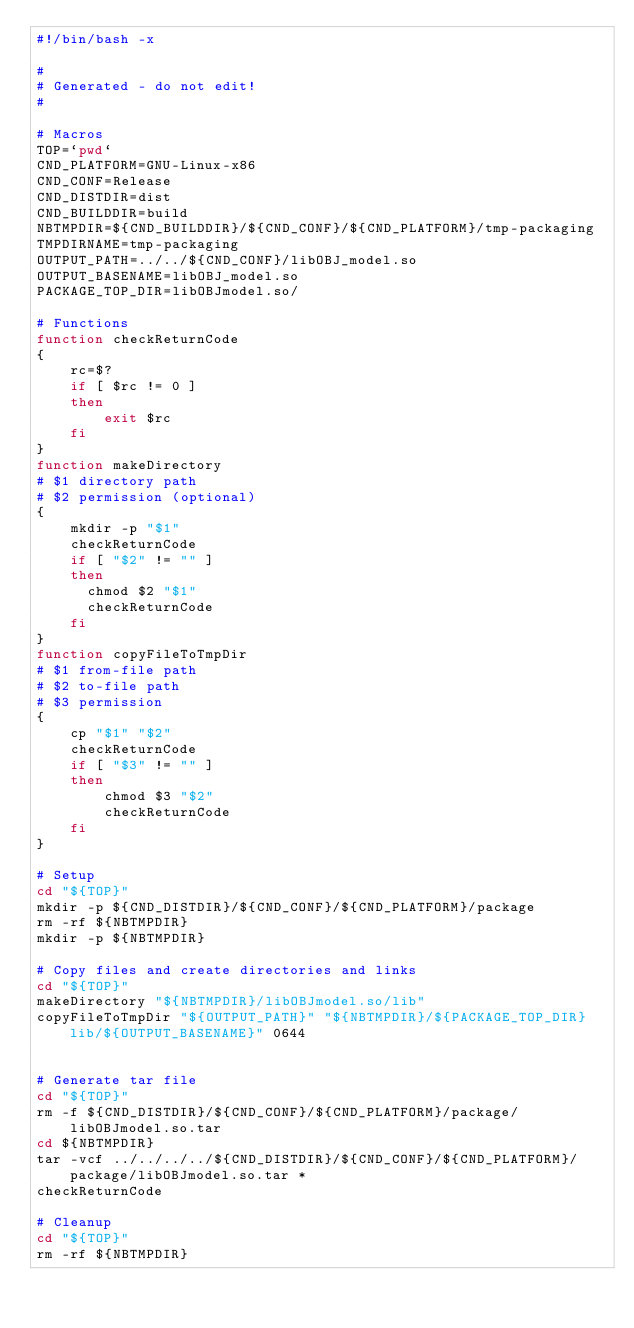Convert code to text. <code><loc_0><loc_0><loc_500><loc_500><_Bash_>#!/bin/bash -x

#
# Generated - do not edit!
#

# Macros
TOP=`pwd`
CND_PLATFORM=GNU-Linux-x86
CND_CONF=Release
CND_DISTDIR=dist
CND_BUILDDIR=build
NBTMPDIR=${CND_BUILDDIR}/${CND_CONF}/${CND_PLATFORM}/tmp-packaging
TMPDIRNAME=tmp-packaging
OUTPUT_PATH=../../${CND_CONF}/libOBJ_model.so
OUTPUT_BASENAME=libOBJ_model.so
PACKAGE_TOP_DIR=libOBJmodel.so/

# Functions
function checkReturnCode
{
    rc=$?
    if [ $rc != 0 ]
    then
        exit $rc
    fi
}
function makeDirectory
# $1 directory path
# $2 permission (optional)
{
    mkdir -p "$1"
    checkReturnCode
    if [ "$2" != "" ]
    then
      chmod $2 "$1"
      checkReturnCode
    fi
}
function copyFileToTmpDir
# $1 from-file path
# $2 to-file path
# $3 permission
{
    cp "$1" "$2"
    checkReturnCode
    if [ "$3" != "" ]
    then
        chmod $3 "$2"
        checkReturnCode
    fi
}

# Setup
cd "${TOP}"
mkdir -p ${CND_DISTDIR}/${CND_CONF}/${CND_PLATFORM}/package
rm -rf ${NBTMPDIR}
mkdir -p ${NBTMPDIR}

# Copy files and create directories and links
cd "${TOP}"
makeDirectory "${NBTMPDIR}/libOBJmodel.so/lib"
copyFileToTmpDir "${OUTPUT_PATH}" "${NBTMPDIR}/${PACKAGE_TOP_DIR}lib/${OUTPUT_BASENAME}" 0644


# Generate tar file
cd "${TOP}"
rm -f ${CND_DISTDIR}/${CND_CONF}/${CND_PLATFORM}/package/libOBJmodel.so.tar
cd ${NBTMPDIR}
tar -vcf ../../../../${CND_DISTDIR}/${CND_CONF}/${CND_PLATFORM}/package/libOBJmodel.so.tar *
checkReturnCode

# Cleanup
cd "${TOP}"
rm -rf ${NBTMPDIR}
</code> 